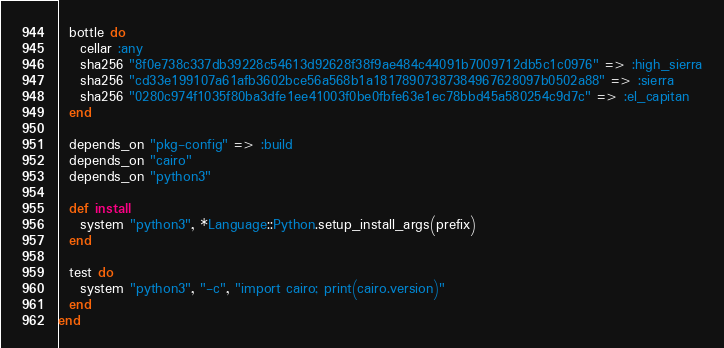<code> <loc_0><loc_0><loc_500><loc_500><_Ruby_>  bottle do
    cellar :any
    sha256 "8f0e738c337db39228c54613d92628f38f9ae484c44091b7009712db5c1c0976" => :high_sierra
    sha256 "cd33e199107a61afb3602bce56a568b1a18178907387384967628097b0502a88" => :sierra
    sha256 "0280c974f1035f80ba3dfe1ee41003f0be0fbfe63e1ec78bbd45a580254c9d7c" => :el_capitan
  end

  depends_on "pkg-config" => :build
  depends_on "cairo"
  depends_on "python3"

  def install
    system "python3", *Language::Python.setup_install_args(prefix)
  end

  test do
    system "python3", "-c", "import cairo; print(cairo.version)"
  end
end
</code> 